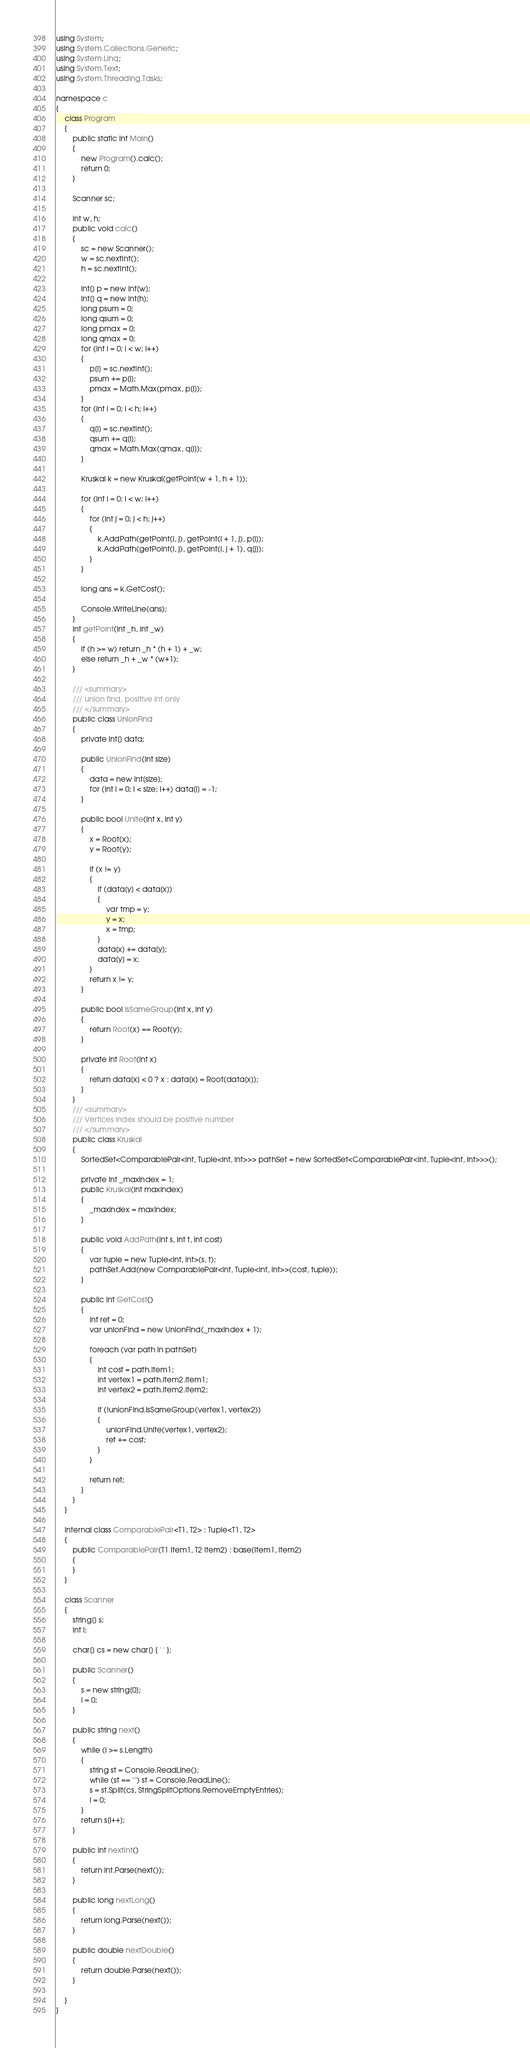Convert code to text. <code><loc_0><loc_0><loc_500><loc_500><_C#_>using System;
using System.Collections.Generic;
using System.Linq;
using System.Text;
using System.Threading.Tasks;

namespace c
{
    class Program
    {
        public static int Main()
        {
            new Program().calc();
            return 0;
        }

        Scanner sc;

        int w, h;
        public void calc()
        {
            sc = new Scanner();
            w = sc.nextInt();
            h = sc.nextInt();

            int[] p = new int[w];
            int[] q = new int[h];
            long psum = 0;
            long qsum = 0;
            long pmax = 0;
            long qmax = 0;
            for (int i = 0; i < w; i++)
            {
                p[i] = sc.nextInt();
                psum += p[i];
                pmax = Math.Max(pmax, p[i]);
            }
            for (int i = 0; i < h; i++)
            {
                q[i] = sc.nextInt();
                qsum += q[i];
                qmax = Math.Max(qmax, q[i]);
            }

            Kruskal k = new Kruskal(getPoint(w + 1, h + 1));

            for (int i = 0; i < w; i++)
            {
                for (int j = 0; j < h; j++)
                {
                    k.AddPath(getPoint(i, j), getPoint(i + 1, j), p[i]);
                    k.AddPath(getPoint(i, j), getPoint(i, j + 1), q[j]);
                }
            }

            long ans = k.GetCost();
                
            Console.WriteLine(ans);
        }
        int getPoint(int _h, int _w)
        {
            if (h >= w) return _h * (h + 1) + _w;
            else return _h + _w * (w+1);
        }

        /// <summary>
        /// union find, positive int only
        /// </summary>
        public class UnionFind
        {
            private int[] data;

            public UnionFind(int size)
            {
                data = new int[size];
                for (int i = 0; i < size; i++) data[i] = -1;
            }

            public bool Unite(int x, int y)
            {
                x = Root(x);
                y = Root(y);

                if (x != y)
                {
                    if (data[y] < data[x])
                    {
                        var tmp = y;
                        y = x;
                        x = tmp;
                    }
                    data[x] += data[y];
                    data[y] = x;
                }
                return x != y;
            }

            public bool IsSameGroup(int x, int y)
            {
                return Root(x) == Root(y);
            }

            private int Root(int x)
            {
                return data[x] < 0 ? x : data[x] = Root(data[x]);
            }
        }
        /// <summary>
        /// Vertices index should be positive number
        /// </summary>
        public class Kruskal
        {
            SortedSet<ComparablePair<int, Tuple<int, int>>> pathSet = new SortedSet<ComparablePair<int, Tuple<int, int>>>();

            private int _maxIndex = 1;
            public Kruskal(int maxIndex)
            {
                _maxIndex = maxIndex;
            }

            public void AddPath(int s, int t, int cost)
            {
                var tuple = new Tuple<int, int>(s, t);
                pathSet.Add(new ComparablePair<int, Tuple<int, int>>(cost, tuple));
            }

            public int GetCost()
            {
                int ret = 0;
                var unionFind = new UnionFind(_maxIndex + 1);

                foreach (var path in pathSet)
                {
                    int cost = path.Item1;
                    int vertex1 = path.Item2.Item1;
                    int vertex2 = path.Item2.Item2;

                    if (!unionFind.IsSameGroup(vertex1, vertex2))
                    {
                        unionFind.Unite(vertex1, vertex2);
                        ret += cost;
                    }
                }

                return ret;
            }
        }
    }

    internal class ComparablePair<T1, T2> : Tuple<T1, T2>
    {
        public ComparablePair(T1 item1, T2 item2) : base(item1, item2)
        {
        }
    }

    class Scanner
    {
        string[] s;
        int i;

        char[] cs = new char[] { ' ' };

        public Scanner()
        {
            s = new string[0];
            i = 0;
        }

        public string next()
        {
            while (i >= s.Length)
            {
                string st = Console.ReadLine();
                while (st == "") st = Console.ReadLine();
                s = st.Split(cs, StringSplitOptions.RemoveEmptyEntries);
                i = 0;
            }
            return s[i++];
        }

        public int nextInt()
        {
            return int.Parse(next());
        }

        public long nextLong()
        {
            return long.Parse(next());
        }

        public double nextDouble()
        {
            return double.Parse(next());
        }

    }
}</code> 